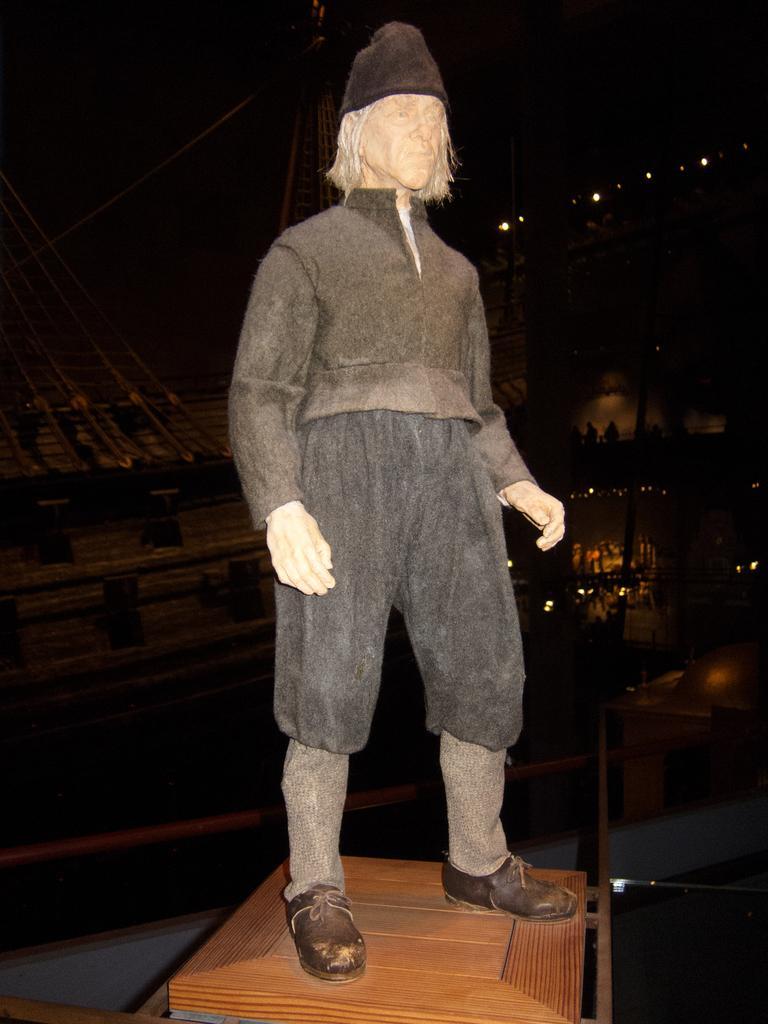How would you summarize this image in a sentence or two? This looks like a statue of a person with clothes, hat and shoes. This statue is placed on the wooden block. The background is not clear enough. 